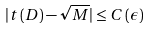<formula> <loc_0><loc_0><loc_500><loc_500>| t \left ( D \right ) - \sqrt { M } | \leq C \left ( \epsilon \right )</formula> 